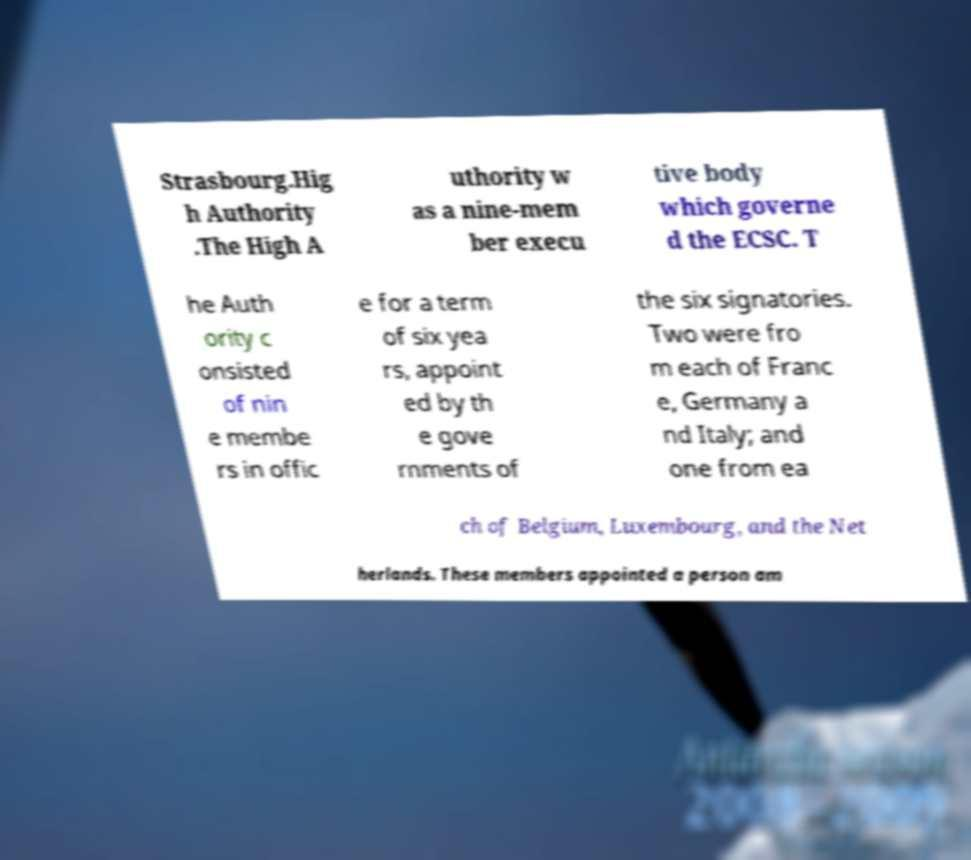Could you extract and type out the text from this image? Strasbourg.Hig h Authority .The High A uthority w as a nine-mem ber execu tive body which governe d the ECSC. T he Auth ority c onsisted of nin e membe rs in offic e for a term of six yea rs, appoint ed by th e gove rnments of the six signatories. Two were fro m each of Franc e, Germany a nd Italy; and one from ea ch of Belgium, Luxembourg, and the Net herlands. These members appointed a person am 